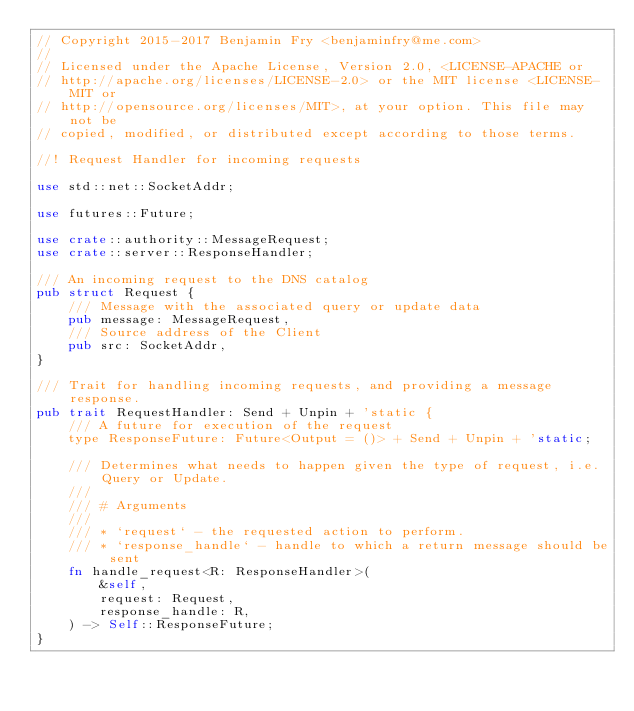<code> <loc_0><loc_0><loc_500><loc_500><_Rust_>// Copyright 2015-2017 Benjamin Fry <benjaminfry@me.com>
//
// Licensed under the Apache License, Version 2.0, <LICENSE-APACHE or
// http://apache.org/licenses/LICENSE-2.0> or the MIT license <LICENSE-MIT or
// http://opensource.org/licenses/MIT>, at your option. This file may not be
// copied, modified, or distributed except according to those terms.

//! Request Handler for incoming requests

use std::net::SocketAddr;

use futures::Future;

use crate::authority::MessageRequest;
use crate::server::ResponseHandler;

/// An incoming request to the DNS catalog
pub struct Request {
    /// Message with the associated query or update data
    pub message: MessageRequest,
    /// Source address of the Client
    pub src: SocketAddr,
}

/// Trait for handling incoming requests, and providing a message response.
pub trait RequestHandler: Send + Unpin + 'static {
    /// A future for execution of the request
    type ResponseFuture: Future<Output = ()> + Send + Unpin + 'static;

    /// Determines what needs to happen given the type of request, i.e. Query or Update.
    ///
    /// # Arguments
    ///
    /// * `request` - the requested action to perform.
    /// * `response_handle` - handle to which a return message should be sent
    fn handle_request<R: ResponseHandler>(
        &self,
        request: Request,
        response_handle: R,
    ) -> Self::ResponseFuture;
}
</code> 